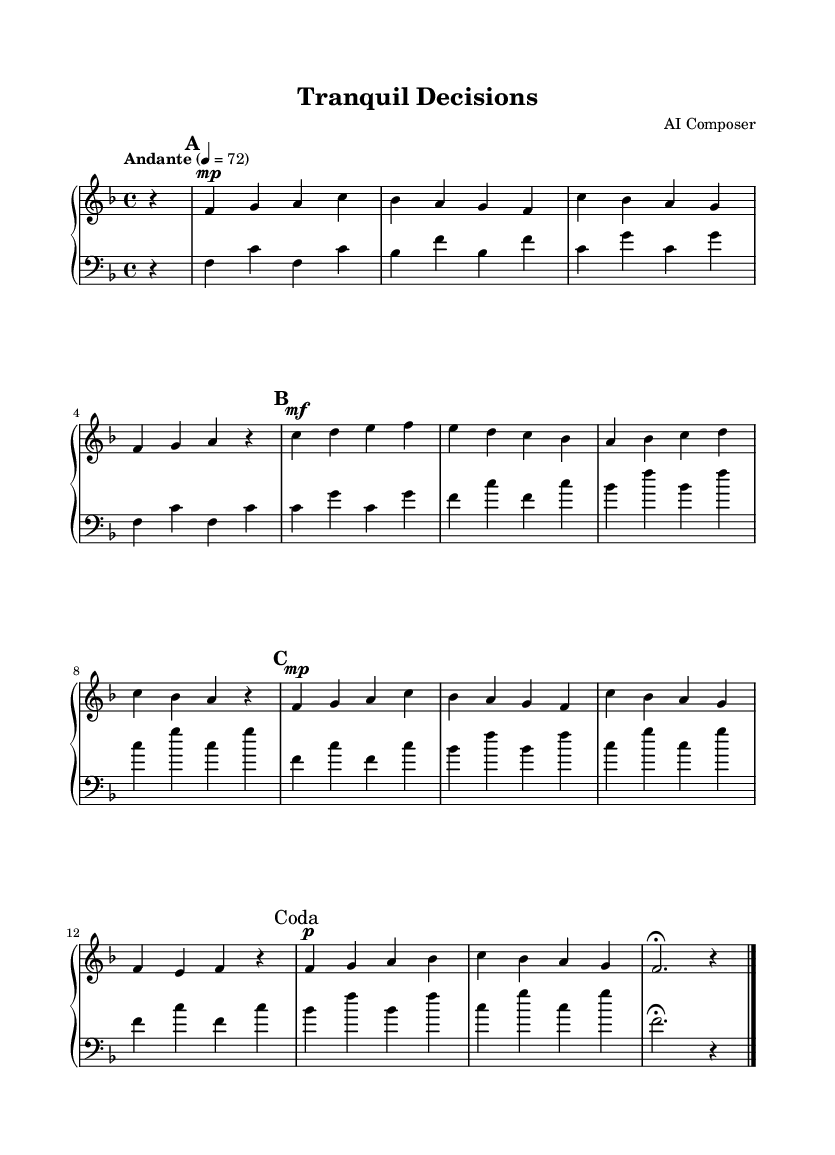What is the key signature of this music? The key signature is F major, which has one flat (B flat). You can tell because the key signature is indicated at the beginning of the staff, showing the B flat.
Answer: F major What is the time signature of this piece? The time signature is 4/4, which is indicated by the notation appearing at the beginning of the sheet music. It means there are four beats in each measure, and the quarter note gets one beat.
Answer: 4/4 What is the tempo marking for this piece? The tempo marking is Andante, which suggests a moderate pace. This notation is found at the beginning, indicating the speed of play.
Answer: Andante How many sections does this composition have? The composition has four sections identified as A, B, A', and Coda. This is determined by the distinct markings labeled at various points in the music.
Answer: Four In which section does the key note 'C' first appear? The key note 'C' first appears in the B section, specifically at the beginning of the second measure of that section, where it is prominently featured.
Answer: B section What dynamic marking is used at the beginning of the A section? The dynamic marking is mezzo-piano, indicating a moderately soft volume. This is clearly indicated at the start of the A section in the right-hand part of the music.
Answer: Mezzo-piano What does the term 'fermata' indicate in the music? The term 'fermata' indicates that the note before it should be held longer than its usual value, allowing for a pause. It is marked above the note in the Coda section, signifying that the performer should extend that note's duration.
Answer: Hold longer 